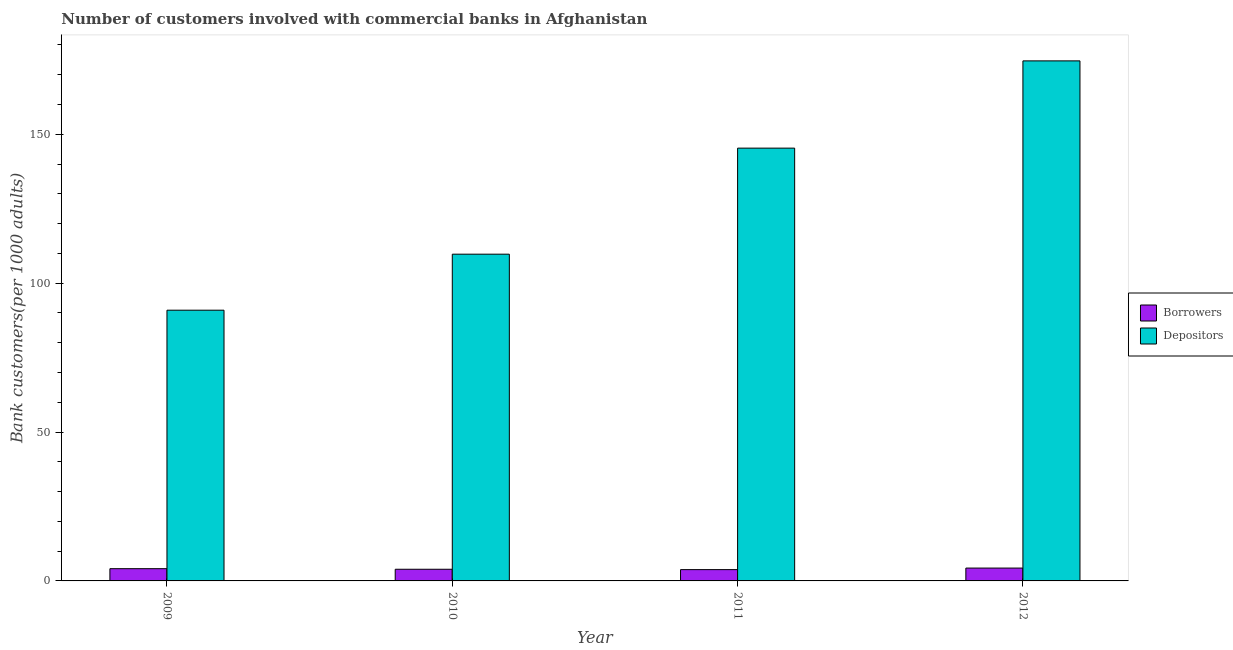How many groups of bars are there?
Your answer should be compact. 4. Are the number of bars on each tick of the X-axis equal?
Provide a succinct answer. Yes. How many bars are there on the 2nd tick from the left?
Offer a terse response. 2. How many bars are there on the 1st tick from the right?
Offer a very short reply. 2. In how many cases, is the number of bars for a given year not equal to the number of legend labels?
Your response must be concise. 0. What is the number of borrowers in 2009?
Keep it short and to the point. 4.11. Across all years, what is the maximum number of borrowers?
Your answer should be compact. 4.31. Across all years, what is the minimum number of borrowers?
Make the answer very short. 3.79. In which year was the number of borrowers maximum?
Provide a succinct answer. 2012. In which year was the number of borrowers minimum?
Your answer should be compact. 2011. What is the total number of borrowers in the graph?
Give a very brief answer. 16.13. What is the difference between the number of borrowers in 2009 and that in 2012?
Your answer should be compact. -0.2. What is the difference between the number of borrowers in 2009 and the number of depositors in 2010?
Make the answer very short. 0.19. What is the average number of borrowers per year?
Provide a succinct answer. 4.03. In how many years, is the number of borrowers greater than 70?
Your answer should be very brief. 0. What is the ratio of the number of borrowers in 2009 to that in 2010?
Offer a very short reply. 1.05. What is the difference between the highest and the second highest number of depositors?
Provide a short and direct response. 29.3. What is the difference between the highest and the lowest number of depositors?
Offer a very short reply. 83.72. In how many years, is the number of depositors greater than the average number of depositors taken over all years?
Give a very brief answer. 2. Is the sum of the number of borrowers in 2010 and 2012 greater than the maximum number of depositors across all years?
Your response must be concise. Yes. What does the 1st bar from the left in 2012 represents?
Make the answer very short. Borrowers. What does the 2nd bar from the right in 2011 represents?
Your answer should be compact. Borrowers. How many bars are there?
Ensure brevity in your answer.  8. Are all the bars in the graph horizontal?
Your answer should be compact. No. Are the values on the major ticks of Y-axis written in scientific E-notation?
Make the answer very short. No. Does the graph contain grids?
Give a very brief answer. No. What is the title of the graph?
Your answer should be very brief. Number of customers involved with commercial banks in Afghanistan. Does "Primary" appear as one of the legend labels in the graph?
Ensure brevity in your answer.  No. What is the label or title of the X-axis?
Offer a very short reply. Year. What is the label or title of the Y-axis?
Provide a succinct answer. Bank customers(per 1000 adults). What is the Bank customers(per 1000 adults) in Borrowers in 2009?
Ensure brevity in your answer.  4.11. What is the Bank customers(per 1000 adults) of Depositors in 2009?
Ensure brevity in your answer.  90.91. What is the Bank customers(per 1000 adults) of Borrowers in 2010?
Provide a short and direct response. 3.92. What is the Bank customers(per 1000 adults) of Depositors in 2010?
Your response must be concise. 109.72. What is the Bank customers(per 1000 adults) of Borrowers in 2011?
Provide a short and direct response. 3.79. What is the Bank customers(per 1000 adults) of Depositors in 2011?
Offer a very short reply. 145.33. What is the Bank customers(per 1000 adults) in Borrowers in 2012?
Your answer should be compact. 4.31. What is the Bank customers(per 1000 adults) of Depositors in 2012?
Make the answer very short. 174.63. Across all years, what is the maximum Bank customers(per 1000 adults) in Borrowers?
Give a very brief answer. 4.31. Across all years, what is the maximum Bank customers(per 1000 adults) of Depositors?
Keep it short and to the point. 174.63. Across all years, what is the minimum Bank customers(per 1000 adults) in Borrowers?
Offer a terse response. 3.79. Across all years, what is the minimum Bank customers(per 1000 adults) of Depositors?
Provide a short and direct response. 90.91. What is the total Bank customers(per 1000 adults) in Borrowers in the graph?
Make the answer very short. 16.13. What is the total Bank customers(per 1000 adults) in Depositors in the graph?
Your answer should be very brief. 520.6. What is the difference between the Bank customers(per 1000 adults) in Borrowers in 2009 and that in 2010?
Provide a succinct answer. 0.19. What is the difference between the Bank customers(per 1000 adults) of Depositors in 2009 and that in 2010?
Give a very brief answer. -18.81. What is the difference between the Bank customers(per 1000 adults) in Borrowers in 2009 and that in 2011?
Make the answer very short. 0.31. What is the difference between the Bank customers(per 1000 adults) of Depositors in 2009 and that in 2011?
Provide a succinct answer. -54.42. What is the difference between the Bank customers(per 1000 adults) in Borrowers in 2009 and that in 2012?
Keep it short and to the point. -0.2. What is the difference between the Bank customers(per 1000 adults) of Depositors in 2009 and that in 2012?
Make the answer very short. -83.72. What is the difference between the Bank customers(per 1000 adults) in Borrowers in 2010 and that in 2011?
Your answer should be compact. 0.12. What is the difference between the Bank customers(per 1000 adults) in Depositors in 2010 and that in 2011?
Your answer should be compact. -35.61. What is the difference between the Bank customers(per 1000 adults) in Borrowers in 2010 and that in 2012?
Keep it short and to the point. -0.4. What is the difference between the Bank customers(per 1000 adults) of Depositors in 2010 and that in 2012?
Make the answer very short. -64.91. What is the difference between the Bank customers(per 1000 adults) of Borrowers in 2011 and that in 2012?
Keep it short and to the point. -0.52. What is the difference between the Bank customers(per 1000 adults) in Depositors in 2011 and that in 2012?
Ensure brevity in your answer.  -29.3. What is the difference between the Bank customers(per 1000 adults) of Borrowers in 2009 and the Bank customers(per 1000 adults) of Depositors in 2010?
Give a very brief answer. -105.61. What is the difference between the Bank customers(per 1000 adults) in Borrowers in 2009 and the Bank customers(per 1000 adults) in Depositors in 2011?
Offer a terse response. -141.22. What is the difference between the Bank customers(per 1000 adults) of Borrowers in 2009 and the Bank customers(per 1000 adults) of Depositors in 2012?
Provide a short and direct response. -170.52. What is the difference between the Bank customers(per 1000 adults) in Borrowers in 2010 and the Bank customers(per 1000 adults) in Depositors in 2011?
Your answer should be compact. -141.41. What is the difference between the Bank customers(per 1000 adults) of Borrowers in 2010 and the Bank customers(per 1000 adults) of Depositors in 2012?
Your answer should be very brief. -170.72. What is the difference between the Bank customers(per 1000 adults) in Borrowers in 2011 and the Bank customers(per 1000 adults) in Depositors in 2012?
Ensure brevity in your answer.  -170.84. What is the average Bank customers(per 1000 adults) of Borrowers per year?
Provide a succinct answer. 4.03. What is the average Bank customers(per 1000 adults) in Depositors per year?
Ensure brevity in your answer.  130.15. In the year 2009, what is the difference between the Bank customers(per 1000 adults) in Borrowers and Bank customers(per 1000 adults) in Depositors?
Keep it short and to the point. -86.8. In the year 2010, what is the difference between the Bank customers(per 1000 adults) in Borrowers and Bank customers(per 1000 adults) in Depositors?
Offer a terse response. -105.81. In the year 2011, what is the difference between the Bank customers(per 1000 adults) of Borrowers and Bank customers(per 1000 adults) of Depositors?
Provide a succinct answer. -141.54. In the year 2012, what is the difference between the Bank customers(per 1000 adults) of Borrowers and Bank customers(per 1000 adults) of Depositors?
Ensure brevity in your answer.  -170.32. What is the ratio of the Bank customers(per 1000 adults) in Borrowers in 2009 to that in 2010?
Your response must be concise. 1.05. What is the ratio of the Bank customers(per 1000 adults) in Depositors in 2009 to that in 2010?
Keep it short and to the point. 0.83. What is the ratio of the Bank customers(per 1000 adults) in Borrowers in 2009 to that in 2011?
Make the answer very short. 1.08. What is the ratio of the Bank customers(per 1000 adults) of Depositors in 2009 to that in 2011?
Your answer should be compact. 0.63. What is the ratio of the Bank customers(per 1000 adults) in Borrowers in 2009 to that in 2012?
Make the answer very short. 0.95. What is the ratio of the Bank customers(per 1000 adults) of Depositors in 2009 to that in 2012?
Offer a very short reply. 0.52. What is the ratio of the Bank customers(per 1000 adults) of Borrowers in 2010 to that in 2011?
Keep it short and to the point. 1.03. What is the ratio of the Bank customers(per 1000 adults) of Depositors in 2010 to that in 2011?
Ensure brevity in your answer.  0.76. What is the ratio of the Bank customers(per 1000 adults) in Borrowers in 2010 to that in 2012?
Provide a succinct answer. 0.91. What is the ratio of the Bank customers(per 1000 adults) of Depositors in 2010 to that in 2012?
Make the answer very short. 0.63. What is the ratio of the Bank customers(per 1000 adults) in Borrowers in 2011 to that in 2012?
Give a very brief answer. 0.88. What is the ratio of the Bank customers(per 1000 adults) of Depositors in 2011 to that in 2012?
Your answer should be compact. 0.83. What is the difference between the highest and the second highest Bank customers(per 1000 adults) of Borrowers?
Your response must be concise. 0.2. What is the difference between the highest and the second highest Bank customers(per 1000 adults) in Depositors?
Ensure brevity in your answer.  29.3. What is the difference between the highest and the lowest Bank customers(per 1000 adults) in Borrowers?
Your answer should be compact. 0.52. What is the difference between the highest and the lowest Bank customers(per 1000 adults) in Depositors?
Offer a terse response. 83.72. 